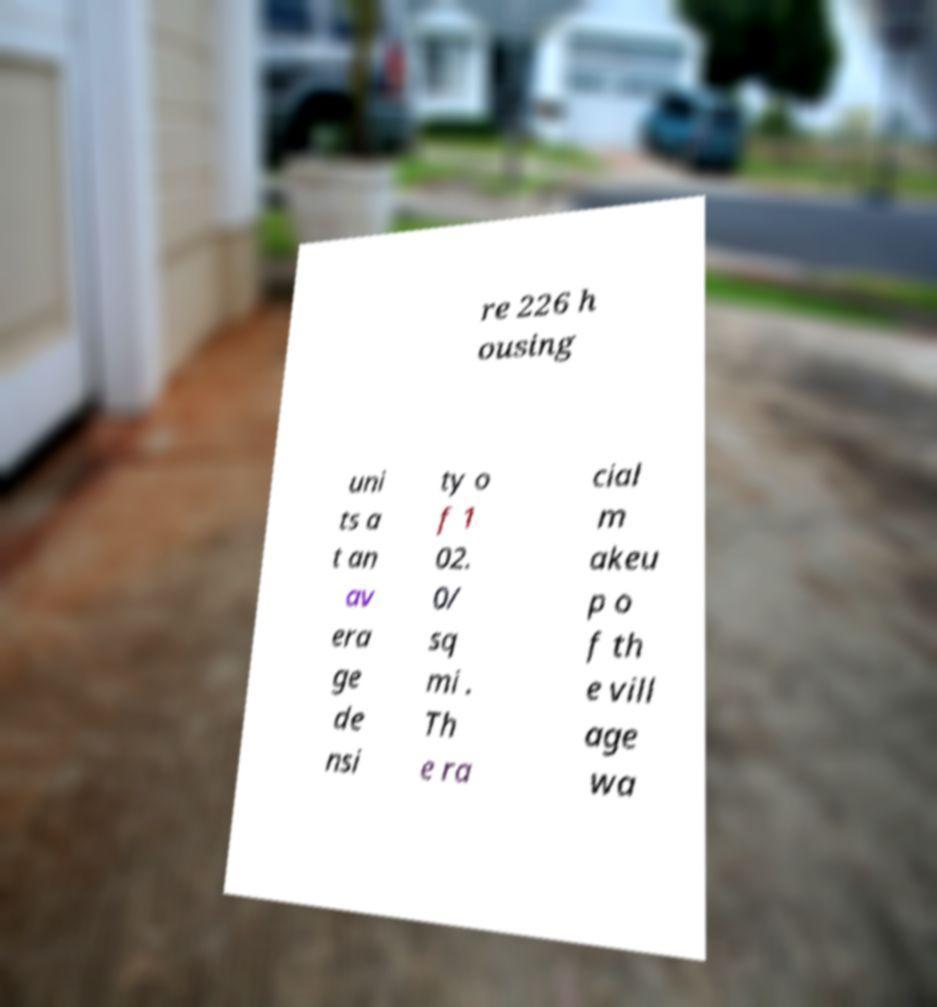Please read and relay the text visible in this image. What does it say? re 226 h ousing uni ts a t an av era ge de nsi ty o f 1 02. 0/ sq mi . Th e ra cial m akeu p o f th e vill age wa 